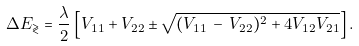<formula> <loc_0><loc_0><loc_500><loc_500>\Delta E _ { \gtrless } = \frac { \lambda } { 2 } \left [ V _ { 1 1 } + V _ { 2 2 } \pm \sqrt { ( V _ { 1 1 } \, - \, V _ { 2 2 } ) ^ { 2 } + 4 V _ { 1 2 } V _ { 2 1 } } \right ] .</formula> 